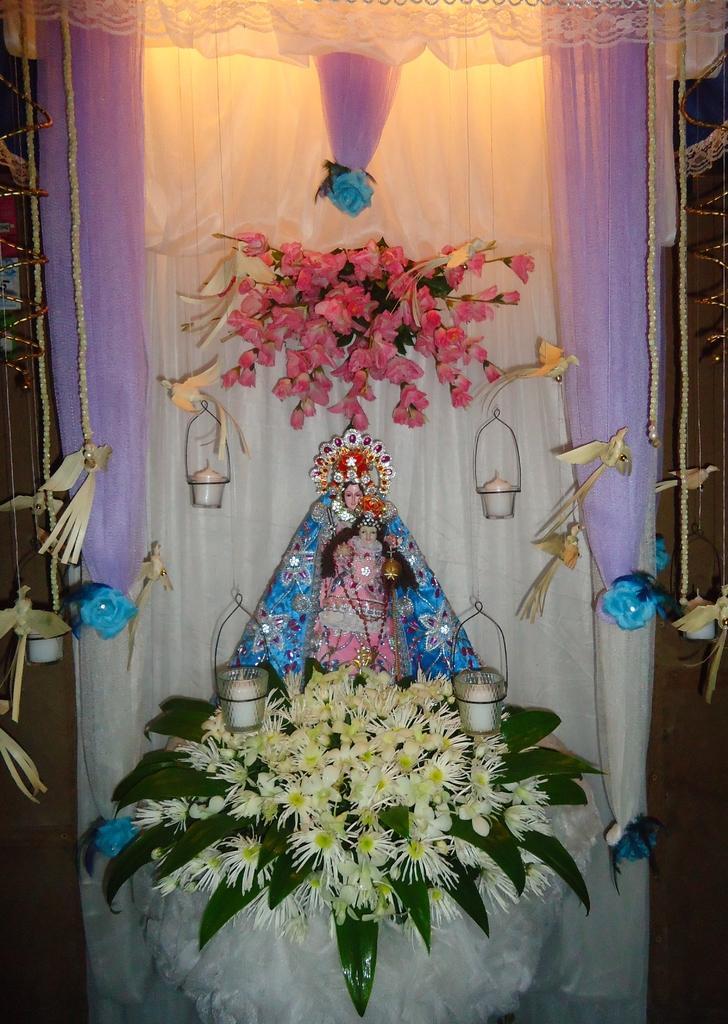Can you describe this image briefly? In the middle of the picture, we see an idol of the goddess, which is decorated with flowers and leaves. Beside that, we see candles and artificial birds. Behind that, we see a white curtain on which flowers are placed and these flowers are in pink color. 